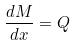<formula> <loc_0><loc_0><loc_500><loc_500>\frac { d M } { d x } = Q</formula> 